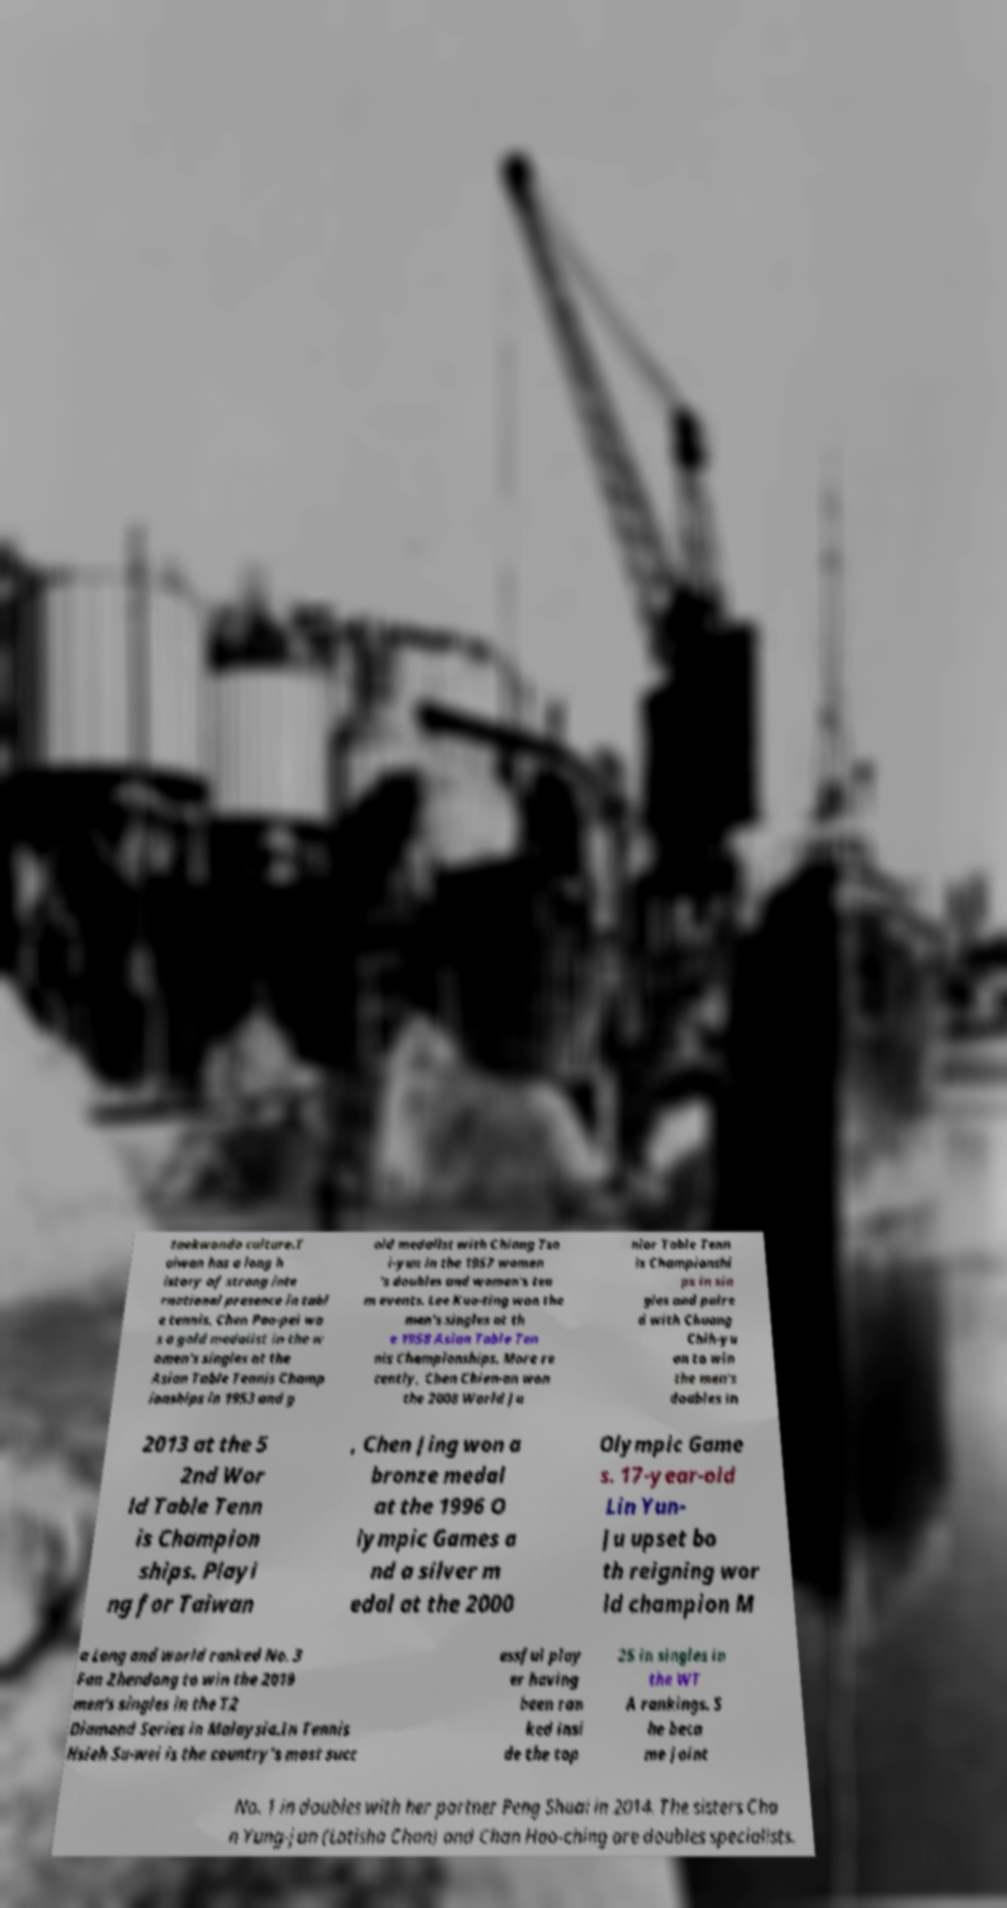Can you read and provide the text displayed in the image?This photo seems to have some interesting text. Can you extract and type it out for me? taekwondo culture.T aiwan has a long h istory of strong inte rnational presence in tabl e tennis. Chen Pao-pei wa s a gold medalist in the w omen's singles at the Asian Table Tennis Champ ionships in 1953 and g old medalist with Chiang Tsa i-yun in the 1957 women 's doubles and women's tea m events. Lee Kuo-ting won the men's singles at th e 1958 Asian Table Ten nis Championships. More re cently, Chen Chien-an won the 2008 World Ju nior Table Tenn is Championshi ps in sin gles and paire d with Chuang Chih-yu an to win the men's doubles in 2013 at the 5 2nd Wor ld Table Tenn is Champion ships. Playi ng for Taiwan , Chen Jing won a bronze medal at the 1996 O lympic Games a nd a silver m edal at the 2000 Olympic Game s. 17-year-old Lin Yun- Ju upset bo th reigning wor ld champion M a Long and world ranked No. 3 Fan Zhendong to win the 2019 men's singles in the T2 Diamond Series in Malaysia.In Tennis Hsieh Su-wei is the country's most succ essful play er having been ran ked insi de the top 25 in singles in the WT A rankings. S he beca me joint No. 1 in doubles with her partner Peng Shuai in 2014. The sisters Cha n Yung-jan (Latisha Chan) and Chan Hao-ching are doubles specialists. 